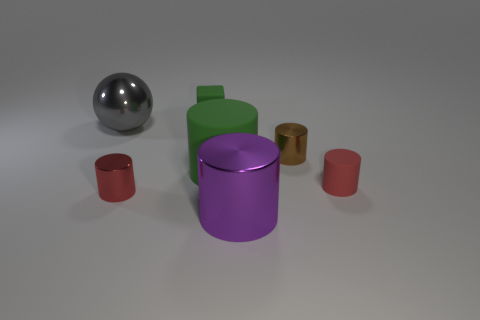There is a green rubber object that is the same size as the red matte cylinder; what shape is it?
Your answer should be compact. Cube. There is another rubber thing that is the same color as the large rubber object; what shape is it?
Make the answer very short. Cube. Is the number of small shiny cylinders that are in front of the gray metal object the same as the number of green cylinders?
Your answer should be compact. No. What is the tiny red object to the left of the tiny shiny cylinder behind the red object behind the small red shiny cylinder made of?
Your response must be concise. Metal. There is a gray object that is made of the same material as the small brown thing; what shape is it?
Provide a succinct answer. Sphere. Is there anything else that is the same color as the tiny rubber cylinder?
Offer a terse response. Yes. There is a big thing that is in front of the small red cylinder that is left of the green rubber block; what number of tiny red cylinders are to the left of it?
Offer a terse response. 1. What number of gray objects are either metallic cubes or large metallic things?
Your answer should be very brief. 1. There is a rubber block; does it have the same size as the green object that is right of the matte cube?
Provide a succinct answer. No. There is a large purple thing that is the same shape as the big green thing; what material is it?
Your response must be concise. Metal. 